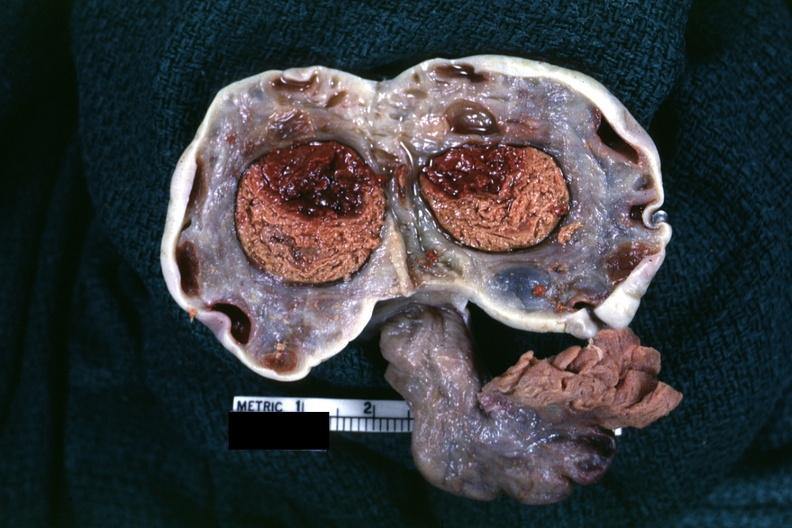s ovary present?
Answer the question using a single word or phrase. Yes 